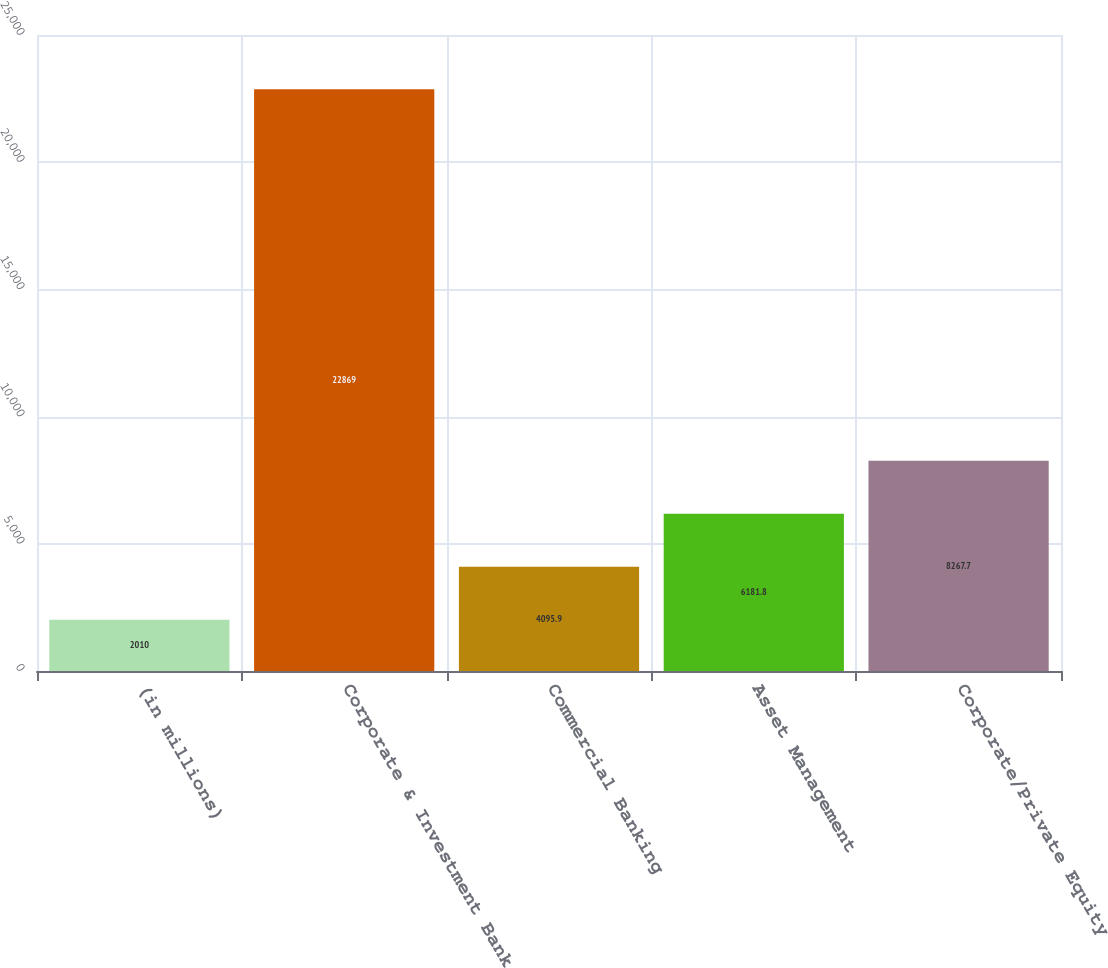<chart> <loc_0><loc_0><loc_500><loc_500><bar_chart><fcel>(in millions)<fcel>Corporate & Investment Bank<fcel>Commercial Banking<fcel>Asset Management<fcel>Corporate/Private Equity<nl><fcel>2010<fcel>22869<fcel>4095.9<fcel>6181.8<fcel>8267.7<nl></chart> 